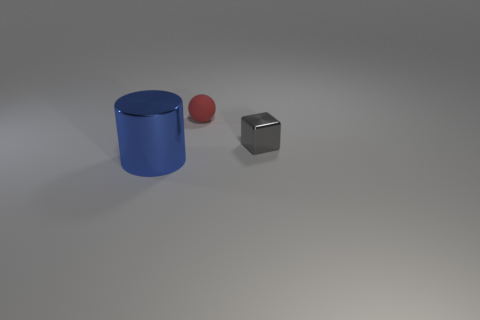Does the red object have the same shape as the tiny gray thing?
Ensure brevity in your answer.  No. What size is the other thing that is the same material as the small gray object?
Your response must be concise. Large. Is the number of small red matte spheres less than the number of large gray shiny cylinders?
Make the answer very short. No. How many large objects are brown cylinders or cylinders?
Keep it short and to the point. 1. How many tiny things are in front of the red matte ball and left of the gray shiny cube?
Keep it short and to the point. 0. Are there more big purple matte cubes than shiny cylinders?
Your answer should be compact. No. How many other objects are the same shape as the small matte object?
Ensure brevity in your answer.  0. What material is the thing that is both in front of the tiny red object and to the left of the small gray cube?
Give a very brief answer. Metal. The blue metal cylinder has what size?
Offer a terse response. Large. There is a tiny thing that is on the right side of the red sphere that is behind the small shiny cube; what number of balls are behind it?
Provide a short and direct response. 1. 